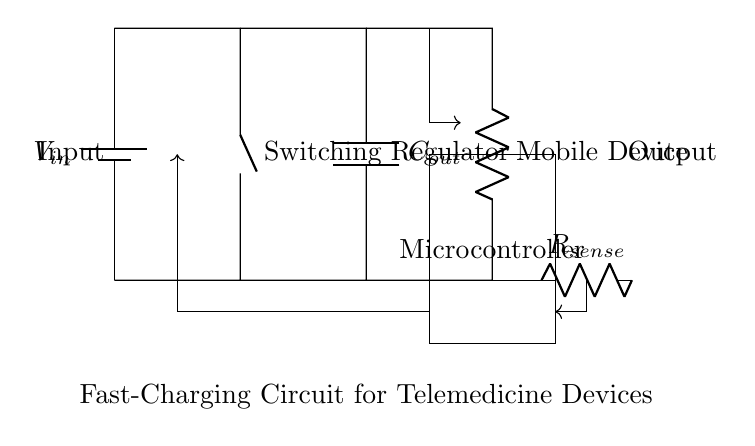What is the input component in this circuit? The input component is a battery, indicated by the symbol with labels. It provides the necessary voltage to power the circuit.
Answer: Battery What does the microcontroller do in this circuit? The microcontroller controls the fast-charging process by regulating the output based on feedback signals from the current sense resistor and voltage inputs.
Answer: Control What is the role of the output capacitor? The output capacitor smooths the output voltage, maintaining a steady supply to the mobile device and preventing voltage spikes during operation.
Answer: Smoothing How is the mobile device connected in this circuit? The mobile device is connected as a load in series with the output capacitor, receiving power from the circuit.
Answer: Series What is the purpose of the current sense resistor? The current sense resistor is used to measure the charging current flowing to the mobile device, providing feedback to the microcontroller for regulation purposes.
Answer: Measurement What component regulates the voltage in this circuit? The switching regulator is the component responsible for regulating the voltage delivered to the load by adjusting the input power efficiently.
Answer: Switching regulator What type of circuit is this primarily used for? This circuit is primarily used for fast-charging mobile devices, particularly in applications like telemedicine where quick charging is essential.
Answer: Fast-charging 